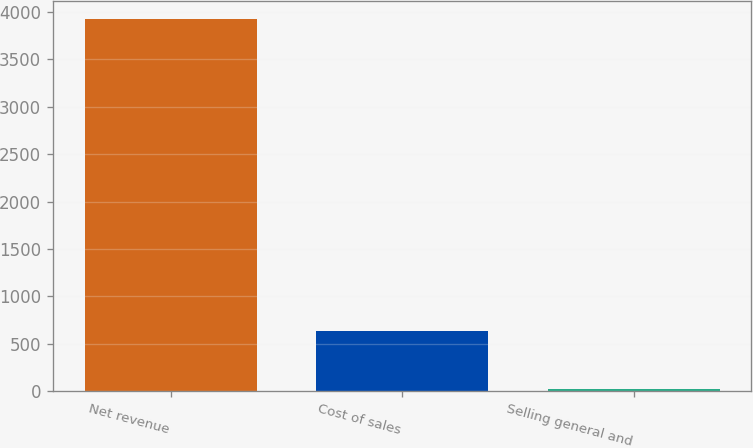Convert chart. <chart><loc_0><loc_0><loc_500><loc_500><bar_chart><fcel>Net revenue<fcel>Cost of sales<fcel>Selling general and<nl><fcel>3922<fcel>634<fcel>24<nl></chart> 